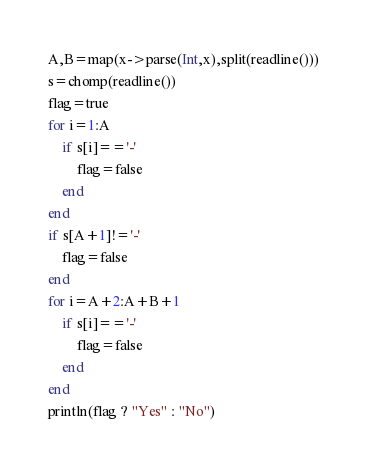<code> <loc_0><loc_0><loc_500><loc_500><_Julia_>A,B=map(x->parse(Int,x),split(readline()))
s=chomp(readline())
flag=true
for i=1:A
	if s[i]=='-'
		flag=false
	end
end
if s[A+1]!='-'
	flag=false
end
for i=A+2:A+B+1
	if s[i]=='-'
		flag=false
	end
end
println(flag ? "Yes" : "No")
</code> 